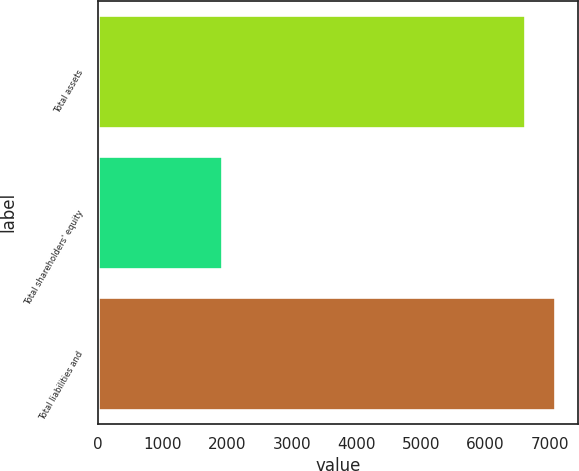Convert chart to OTSL. <chart><loc_0><loc_0><loc_500><loc_500><bar_chart><fcel>Total assets<fcel>Total shareholders' equity<fcel>Total liabilities and<nl><fcel>6610<fcel>1913<fcel>7079.7<nl></chart> 